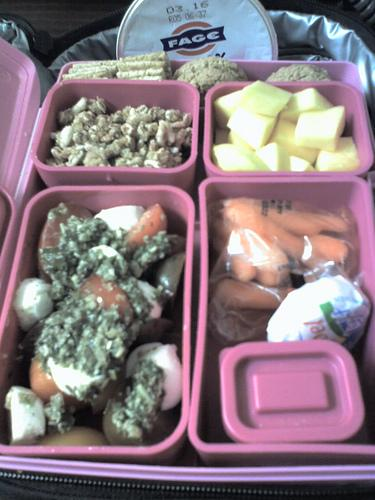What does the company whose logo appears at the top specialize in? yogurt 